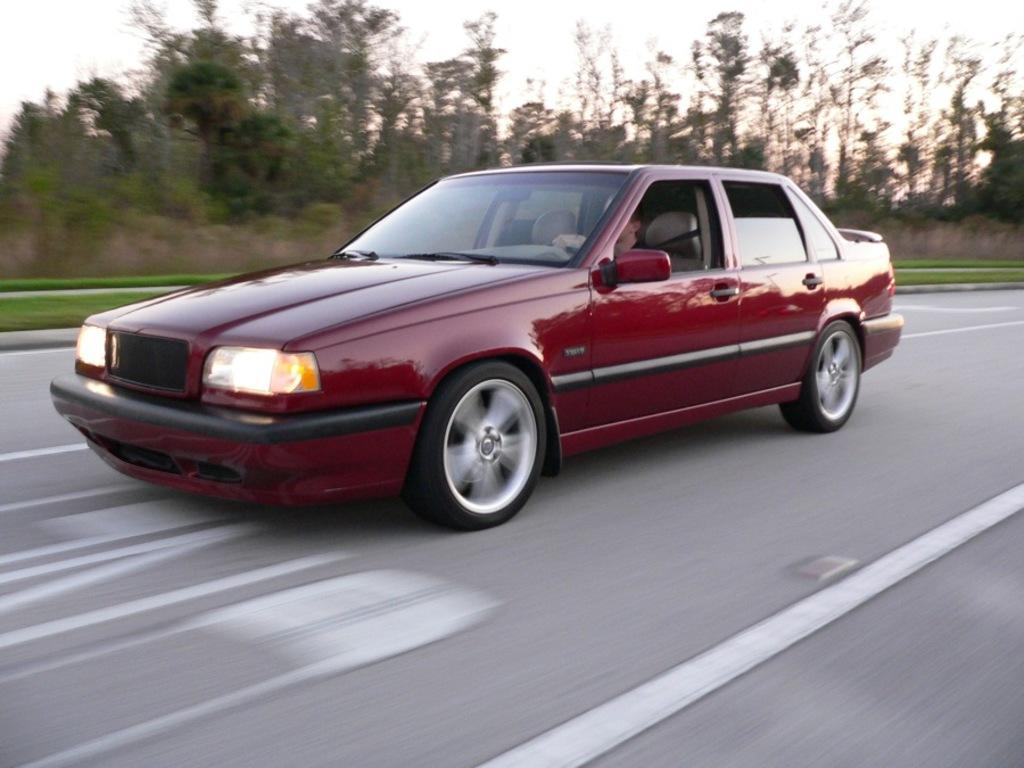What is the person in the image doing? The person is driving a car in the image. Where is the car located? The car is on the road in the image. What type of vegetation can be seen in the image? There are trees, plants, and grass visible in the image. What is visible in the background of the image? The sky is visible in the image. What is the person's health condition in the image? There is no information about the person's health condition in the image. What type of road is the car driving on in the image? There is no specific information about the type of road in the image, only that the car is on the road. 